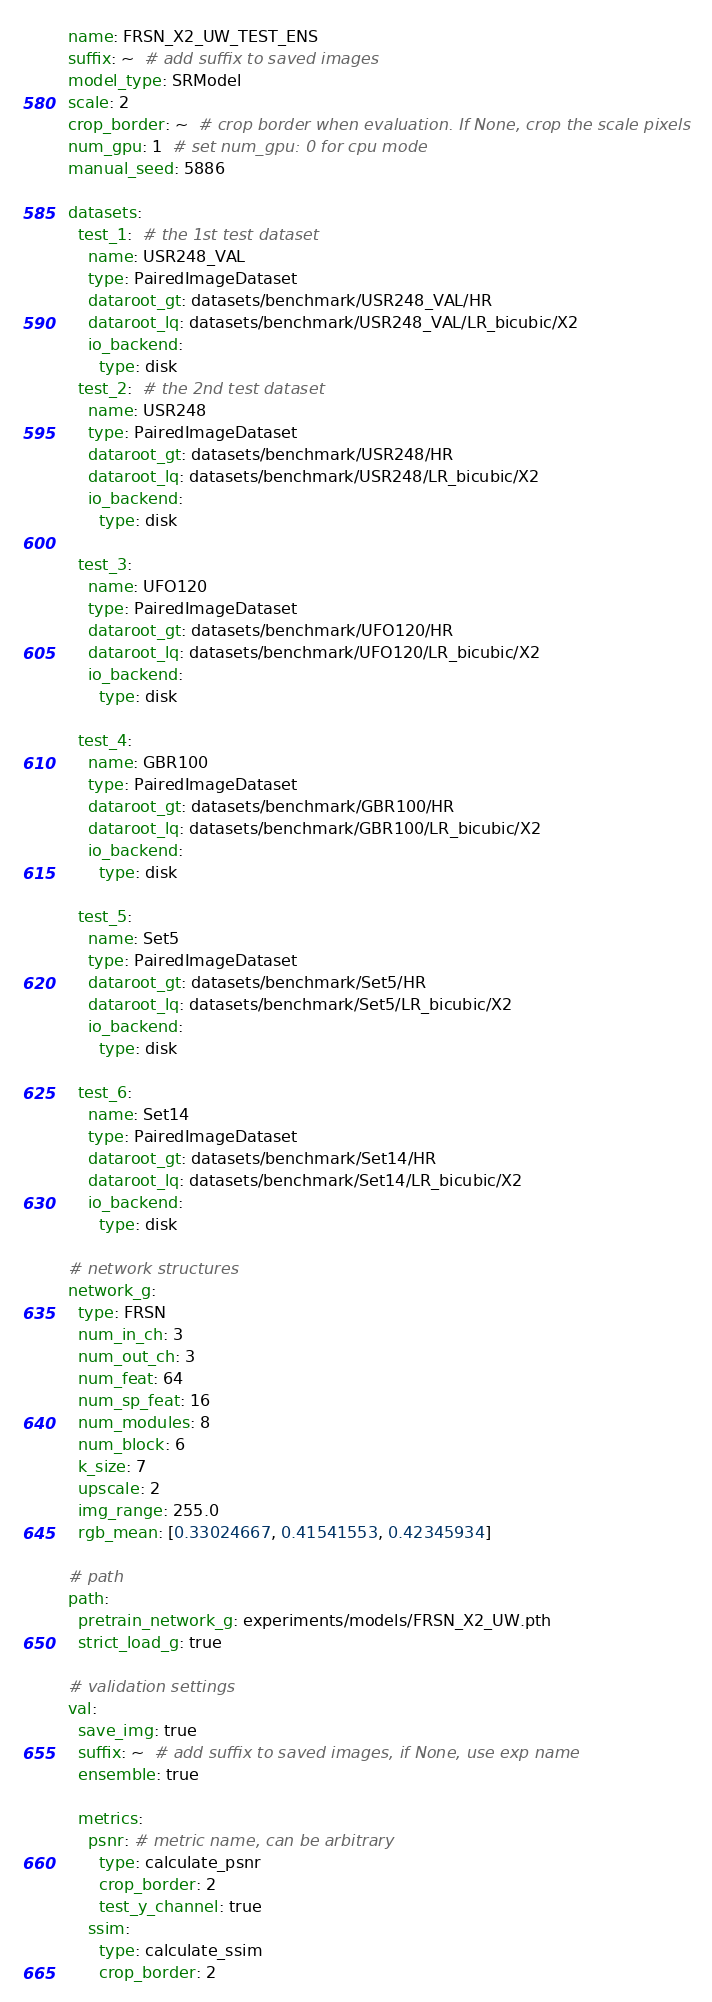<code> <loc_0><loc_0><loc_500><loc_500><_YAML_>name: FRSN_X2_UW_TEST_ENS
suffix: ~  # add suffix to saved images
model_type: SRModel
scale: 2
crop_border: ~  # crop border when evaluation. If None, crop the scale pixels
num_gpu: 1  # set num_gpu: 0 for cpu mode
manual_seed: 5886

datasets:
  test_1:  # the 1st test dataset
    name: USR248_VAL
    type: PairedImageDataset
    dataroot_gt: datasets/benchmark/USR248_VAL/HR
    dataroot_lq: datasets/benchmark/USR248_VAL/LR_bicubic/X2
    io_backend:
      type: disk
  test_2:  # the 2nd test dataset
    name: USR248
    type: PairedImageDataset
    dataroot_gt: datasets/benchmark/USR248/HR
    dataroot_lq: datasets/benchmark/USR248/LR_bicubic/X2
    io_backend:
      type: disk

  test_3:
    name: UFO120
    type: PairedImageDataset
    dataroot_gt: datasets/benchmark/UFO120/HR
    dataroot_lq: datasets/benchmark/UFO120/LR_bicubic/X2
    io_backend:
      type: disk

  test_4:
    name: GBR100
    type: PairedImageDataset
    dataroot_gt: datasets/benchmark/GBR100/HR
    dataroot_lq: datasets/benchmark/GBR100/LR_bicubic/X2
    io_backend:
      type: disk

  test_5:
    name: Set5
    type: PairedImageDataset
    dataroot_gt: datasets/benchmark/Set5/HR
    dataroot_lq: datasets/benchmark/Set5/LR_bicubic/X2
    io_backend:
      type: disk

  test_6:
    name: Set14
    type: PairedImageDataset
    dataroot_gt: datasets/benchmark/Set14/HR
    dataroot_lq: datasets/benchmark/Set14/LR_bicubic/X2
    io_backend:
      type: disk

# network structures
network_g:
  type: FRSN
  num_in_ch: 3
  num_out_ch: 3
  num_feat: 64
  num_sp_feat: 16
  num_modules: 8
  num_block: 6
  k_size: 7
  upscale: 2
  img_range: 255.0
  rgb_mean: [0.33024667, 0.41541553, 0.42345934]

# path
path:
  pretrain_network_g: experiments/models/FRSN_X2_UW.pth
  strict_load_g: true

# validation settings
val:
  save_img: true
  suffix: ~  # add suffix to saved images, if None, use exp name
  ensemble: true

  metrics:
    psnr: # metric name, can be arbitrary
      type: calculate_psnr
      crop_border: 2
      test_y_channel: true
    ssim:
      type: calculate_ssim
      crop_border: 2</code> 